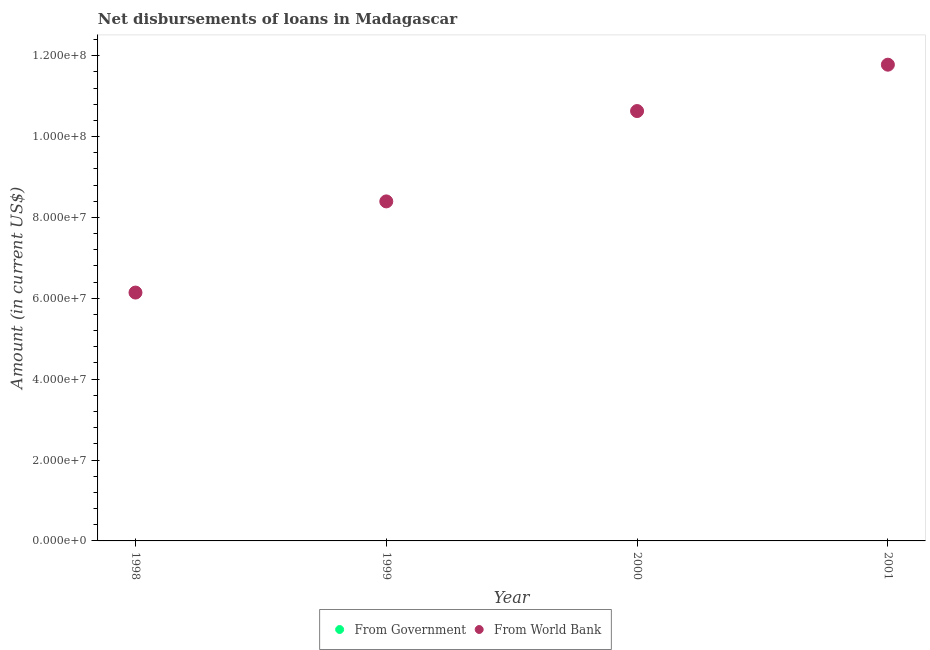Is the number of dotlines equal to the number of legend labels?
Offer a very short reply. No. What is the net disbursements of loan from world bank in 1999?
Your response must be concise. 8.40e+07. Across all years, what is the maximum net disbursements of loan from world bank?
Ensure brevity in your answer.  1.18e+08. Across all years, what is the minimum net disbursements of loan from world bank?
Offer a very short reply. 6.14e+07. What is the total net disbursements of loan from world bank in the graph?
Provide a succinct answer. 3.69e+08. What is the difference between the net disbursements of loan from world bank in 1998 and that in 2001?
Give a very brief answer. -5.64e+07. What is the difference between the net disbursements of loan from world bank in 2001 and the net disbursements of loan from government in 1998?
Your answer should be compact. 1.18e+08. What is the average net disbursements of loan from world bank per year?
Offer a very short reply. 9.24e+07. What is the ratio of the net disbursements of loan from world bank in 2000 to that in 2001?
Provide a succinct answer. 0.9. What is the difference between the highest and the second highest net disbursements of loan from world bank?
Offer a terse response. 1.15e+07. What is the difference between the highest and the lowest net disbursements of loan from world bank?
Give a very brief answer. 5.64e+07. In how many years, is the net disbursements of loan from government greater than the average net disbursements of loan from government taken over all years?
Provide a short and direct response. 0. Is the sum of the net disbursements of loan from world bank in 1998 and 1999 greater than the maximum net disbursements of loan from government across all years?
Provide a short and direct response. Yes. Is the net disbursements of loan from government strictly greater than the net disbursements of loan from world bank over the years?
Ensure brevity in your answer.  No. How many years are there in the graph?
Your response must be concise. 4. What is the difference between two consecutive major ticks on the Y-axis?
Ensure brevity in your answer.  2.00e+07. Does the graph contain grids?
Give a very brief answer. No. Where does the legend appear in the graph?
Make the answer very short. Bottom center. How many legend labels are there?
Offer a very short reply. 2. How are the legend labels stacked?
Provide a short and direct response. Horizontal. What is the title of the graph?
Keep it short and to the point. Net disbursements of loans in Madagascar. Does "Methane" appear as one of the legend labels in the graph?
Your answer should be compact. No. What is the label or title of the Y-axis?
Ensure brevity in your answer.  Amount (in current US$). What is the Amount (in current US$) of From World Bank in 1998?
Offer a terse response. 6.14e+07. What is the Amount (in current US$) of From Government in 1999?
Your answer should be compact. 0. What is the Amount (in current US$) of From World Bank in 1999?
Make the answer very short. 8.40e+07. What is the Amount (in current US$) in From World Bank in 2000?
Ensure brevity in your answer.  1.06e+08. What is the Amount (in current US$) in From Government in 2001?
Ensure brevity in your answer.  0. What is the Amount (in current US$) in From World Bank in 2001?
Offer a terse response. 1.18e+08. Across all years, what is the maximum Amount (in current US$) in From World Bank?
Ensure brevity in your answer.  1.18e+08. Across all years, what is the minimum Amount (in current US$) of From World Bank?
Keep it short and to the point. 6.14e+07. What is the total Amount (in current US$) in From World Bank in the graph?
Ensure brevity in your answer.  3.69e+08. What is the difference between the Amount (in current US$) of From World Bank in 1998 and that in 1999?
Ensure brevity in your answer.  -2.25e+07. What is the difference between the Amount (in current US$) in From World Bank in 1998 and that in 2000?
Offer a terse response. -4.49e+07. What is the difference between the Amount (in current US$) in From World Bank in 1998 and that in 2001?
Ensure brevity in your answer.  -5.64e+07. What is the difference between the Amount (in current US$) in From World Bank in 1999 and that in 2000?
Give a very brief answer. -2.23e+07. What is the difference between the Amount (in current US$) of From World Bank in 1999 and that in 2001?
Your answer should be compact. -3.38e+07. What is the difference between the Amount (in current US$) of From World Bank in 2000 and that in 2001?
Your answer should be compact. -1.15e+07. What is the average Amount (in current US$) in From Government per year?
Provide a succinct answer. 0. What is the average Amount (in current US$) of From World Bank per year?
Your answer should be compact. 9.24e+07. What is the ratio of the Amount (in current US$) in From World Bank in 1998 to that in 1999?
Offer a terse response. 0.73. What is the ratio of the Amount (in current US$) of From World Bank in 1998 to that in 2000?
Your answer should be compact. 0.58. What is the ratio of the Amount (in current US$) of From World Bank in 1998 to that in 2001?
Your answer should be very brief. 0.52. What is the ratio of the Amount (in current US$) of From World Bank in 1999 to that in 2000?
Keep it short and to the point. 0.79. What is the ratio of the Amount (in current US$) in From World Bank in 1999 to that in 2001?
Provide a succinct answer. 0.71. What is the ratio of the Amount (in current US$) of From World Bank in 2000 to that in 2001?
Keep it short and to the point. 0.9. What is the difference between the highest and the second highest Amount (in current US$) of From World Bank?
Your response must be concise. 1.15e+07. What is the difference between the highest and the lowest Amount (in current US$) of From World Bank?
Offer a very short reply. 5.64e+07. 